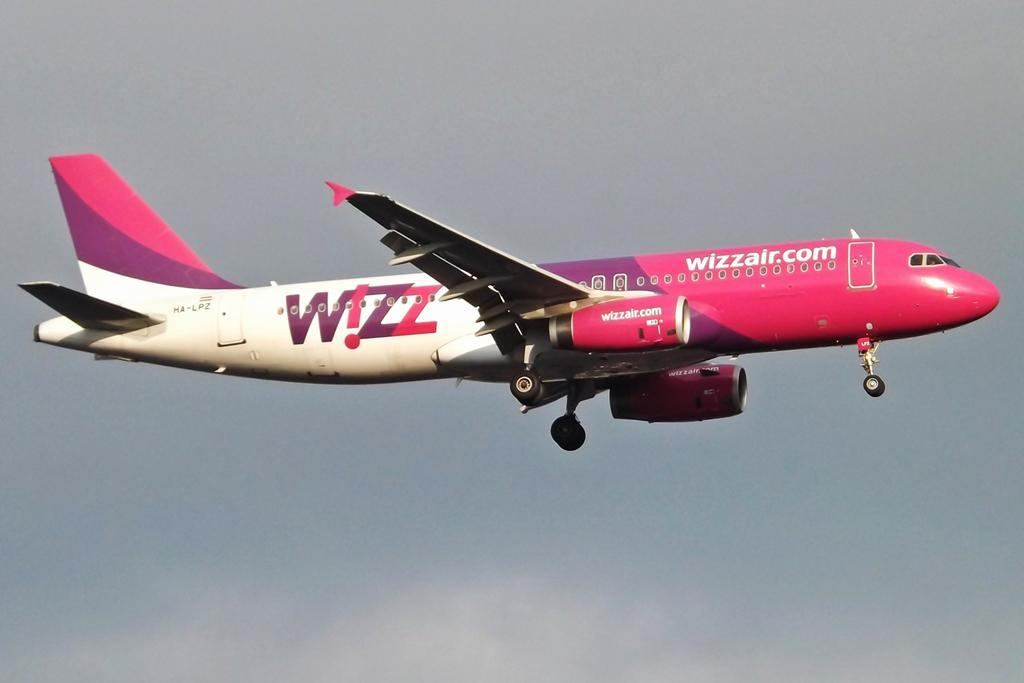<image>
Share a concise interpretation of the image provided. A Wizz Air jet is flying across a cloudy sky. 